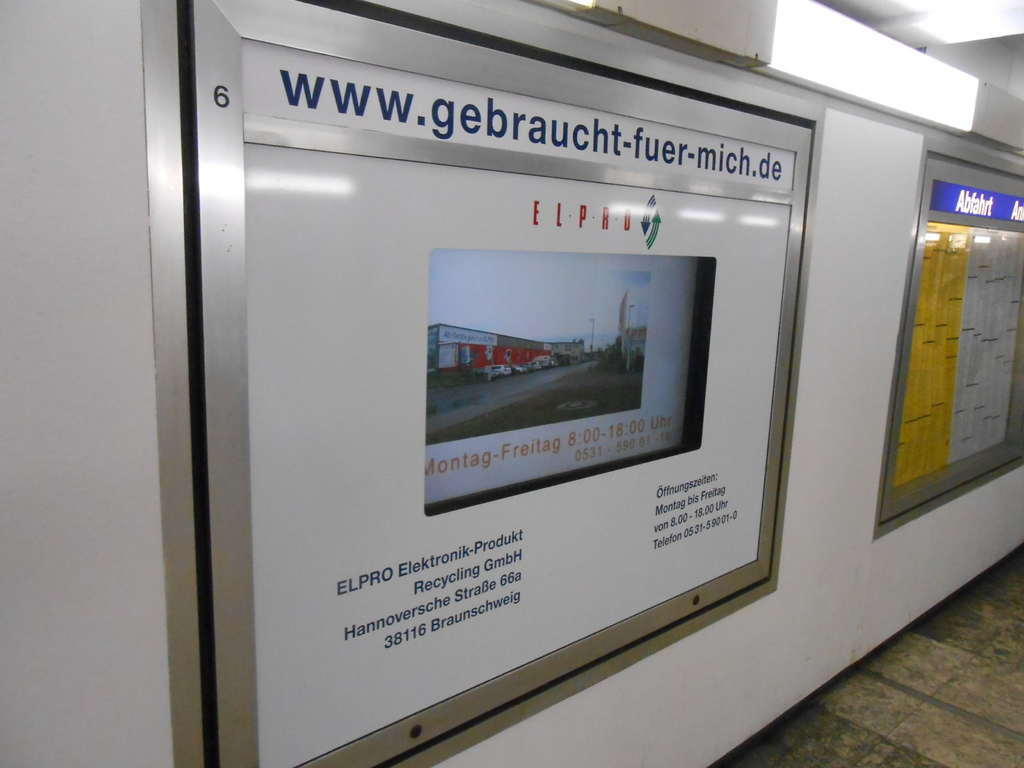Why might the ad be placed in a subway station? Placing the ad in a subway station targets a high volume of daily commuters who are likely to use electronic products and could benefit from recycling services. It's an effective way to raise awareness about the importance of electronics recycling and to encourage individuals to consider recycling their old electronics. 